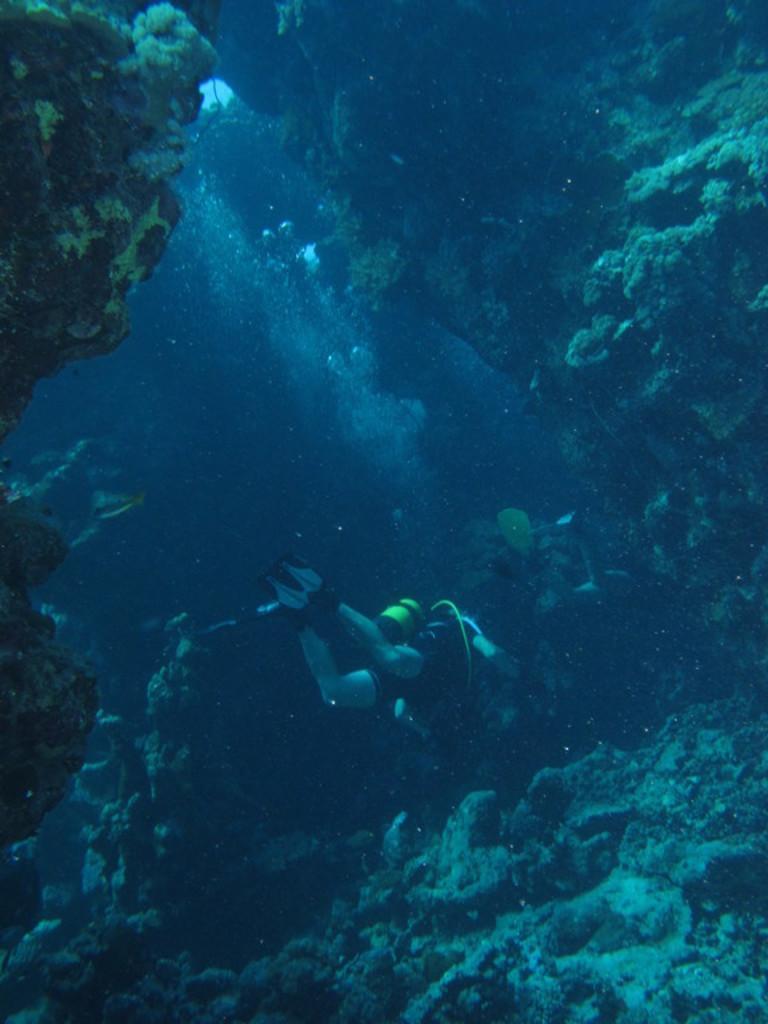Describe this image in one or two sentences. This image is taken under the water. In the center of the image there is a person swimming. There are stones. 